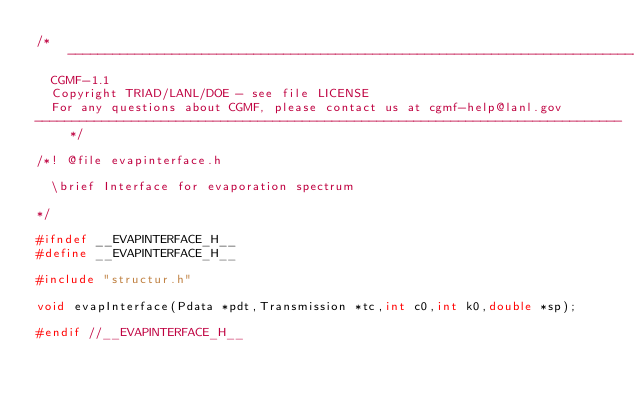<code> <loc_0><loc_0><loc_500><loc_500><_C_>/*------------------------------------------------------------------------------
  CGMF-1.1
  Copyright TRIAD/LANL/DOE - see file LICENSE
  For any questions about CGMF, please contact us at cgmf-help@lanl.gov
-------------------------------------------------------------------------------*/

/*! @file evapinterface.h

  \brief Interface for evaporation spectrum

*/

#ifndef __EVAPINTERFACE_H__
#define __EVAPINTERFACE_H__

#include "structur.h"

void evapInterface(Pdata *pdt,Transmission *tc,int c0,int k0,double *sp);

#endif //__EVAPINTERFACE_H__
</code> 